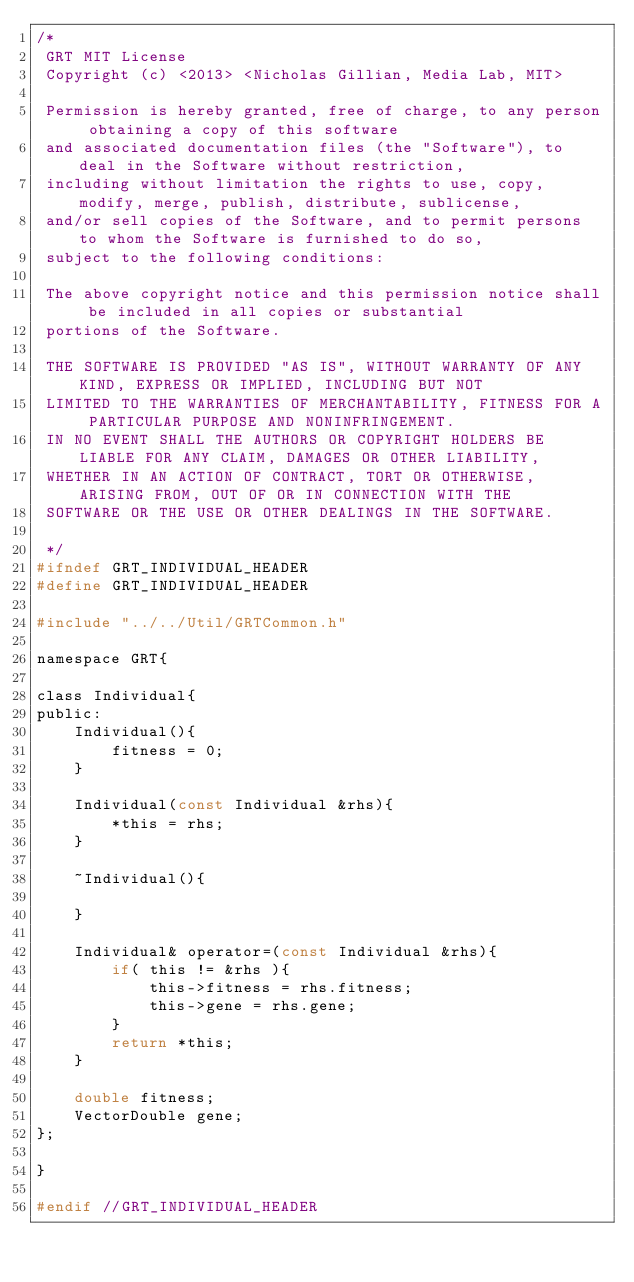<code> <loc_0><loc_0><loc_500><loc_500><_C_>/*
 GRT MIT License
 Copyright (c) <2013> <Nicholas Gillian, Media Lab, MIT>
 
 Permission is hereby granted, free of charge, to any person obtaining a copy of this software
 and associated documentation files (the "Software"), to deal in the Software without restriction,
 including without limitation the rights to use, copy, modify, merge, publish, distribute, sublicense,
 and/or sell copies of the Software, and to permit persons to whom the Software is furnished to do so,
 subject to the following conditions:
 
 The above copyright notice and this permission notice shall be included in all copies or substantial
 portions of the Software.
 
 THE SOFTWARE IS PROVIDED "AS IS", WITHOUT WARRANTY OF ANY KIND, EXPRESS OR IMPLIED, INCLUDING BUT NOT
 LIMITED TO THE WARRANTIES OF MERCHANTABILITY, FITNESS FOR A PARTICULAR PURPOSE AND NONINFRINGEMENT.
 IN NO EVENT SHALL THE AUTHORS OR COPYRIGHT HOLDERS BE LIABLE FOR ANY CLAIM, DAMAGES OR OTHER LIABILITY,
 WHETHER IN AN ACTION OF CONTRACT, TORT OR OTHERWISE, ARISING FROM, OUT OF OR IN CONNECTION WITH THE
 SOFTWARE OR THE USE OR OTHER DEALINGS IN THE SOFTWARE.
 
 */
#ifndef GRT_INDIVIDUAL_HEADER
#define GRT_INDIVIDUAL_HEADER

#include "../../Util/GRTCommon.h"

namespace GRT{
    
class Individual{
public:
    Individual(){
        fitness = 0;
    }
    
    Individual(const Individual &rhs){
        *this = rhs;
    }
    
    ~Individual(){
        
    }
    
    Individual& operator=(const Individual &rhs){
        if( this != &rhs ){
            this->fitness = rhs.fitness;
            this->gene = rhs.gene;
        }
        return *this;
    }
    
    double fitness;
    VectorDouble gene;
};
    
}

#endif //GRT_INDIVIDUAL_HEADER
</code> 